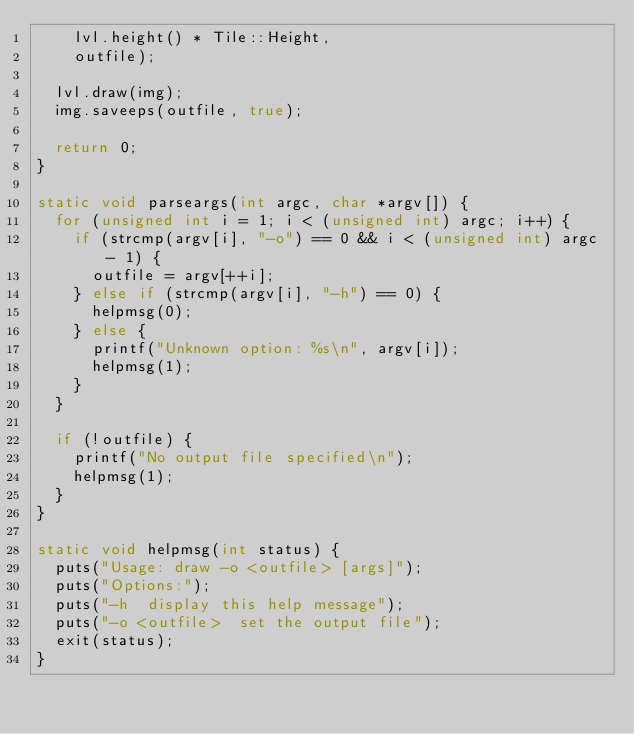Convert code to text. <code><loc_0><loc_0><loc_500><loc_500><_C++_>		lvl.height() * Tile::Height,
		outfile);

	lvl.draw(img);
	img.saveeps(outfile, true);

	return 0;
}

static void parseargs(int argc, char *argv[]) {
	for (unsigned int i = 1; i < (unsigned int) argc; i++) {
		if (strcmp(argv[i], "-o") == 0 && i < (unsigned int) argc - 1) {
			outfile = argv[++i];
		} else if (strcmp(argv[i], "-h") == 0) {
			helpmsg(0);
		} else {
			printf("Unknown option: %s\n", argv[i]);
			helpmsg(1);
		}
	}

	if (!outfile) {
		printf("No output file specified\n");
		helpmsg(1);
	}
}

static void helpmsg(int status) {
	puts("Usage: draw -o <outfile> [args]");
	puts("Options:");
	puts("-h	display this help message");
	puts("-o <outfile>	set the output file");
	exit(status);
}</code> 